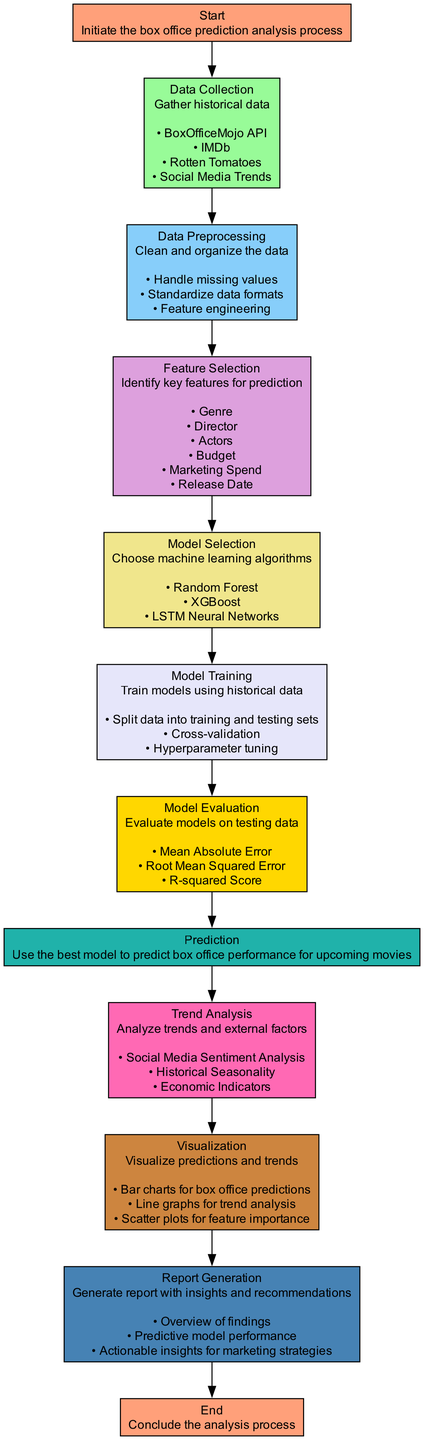What is the first step in the flowchart? The first step in the flowchart is labeled "Start," indicating the initiation of the box office prediction analysis process.
Answer: Start How many steps are involved in the entire process? By counting the steps listed in the flowchart, there are a total of 11 steps from Start to End.
Answer: 11 Which step involves cleaning and organizing the data? The step labeled "Data Preprocessing" specifically includes actions for cleaning and organizing the data.
Answer: Data Preprocessing What is the last step of the analysis process? The last step in the flowchart is "End," which concludes the box office prediction analysis process.
Answer: End Which machine learning algorithms are selected for model training? The flowchart lists three algorithms: "Random Forest," "XGBoost," and "LSTM Neural Networks" as options for model selection.
Answer: Random Forest, XGBoost, LSTM Neural Networks What analysis is performed after making predictions? The step labeled "Trend Analysis" follows the prediction and focuses on analyzing external factors and trends.
Answer: Trend Analysis How is the model performance evaluated? The flowchart shows that model evaluation involves techniques like "Mean Absolute Error," "Root Mean Squared Error," and "R-squared Score."
Answer: Mean Absolute Error, Root Mean Squared Error, R-squared Score What type of visualization is created for trend analysis? The visualization for trend analysis is represented by "Line graphs," according to the details in the flowchart.
Answer: Line graphs How does the flowchart indicate the use of external data sources? The "Data Collection" step lists a variety of sources including BoxOfficeMojo API, IMDb, Rotten Tomatoes, and Social Media Trends, indicating how external data is incorporated.
Answer: BoxOfficeMojo API, IMDb, Rotten Tomatoes, Social Media Trends 